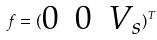Convert formula to latex. <formula><loc_0><loc_0><loc_500><loc_500>f = ( \begin{matrix} 0 & 0 & V _ { s } \end{matrix} ) ^ { T }</formula> 